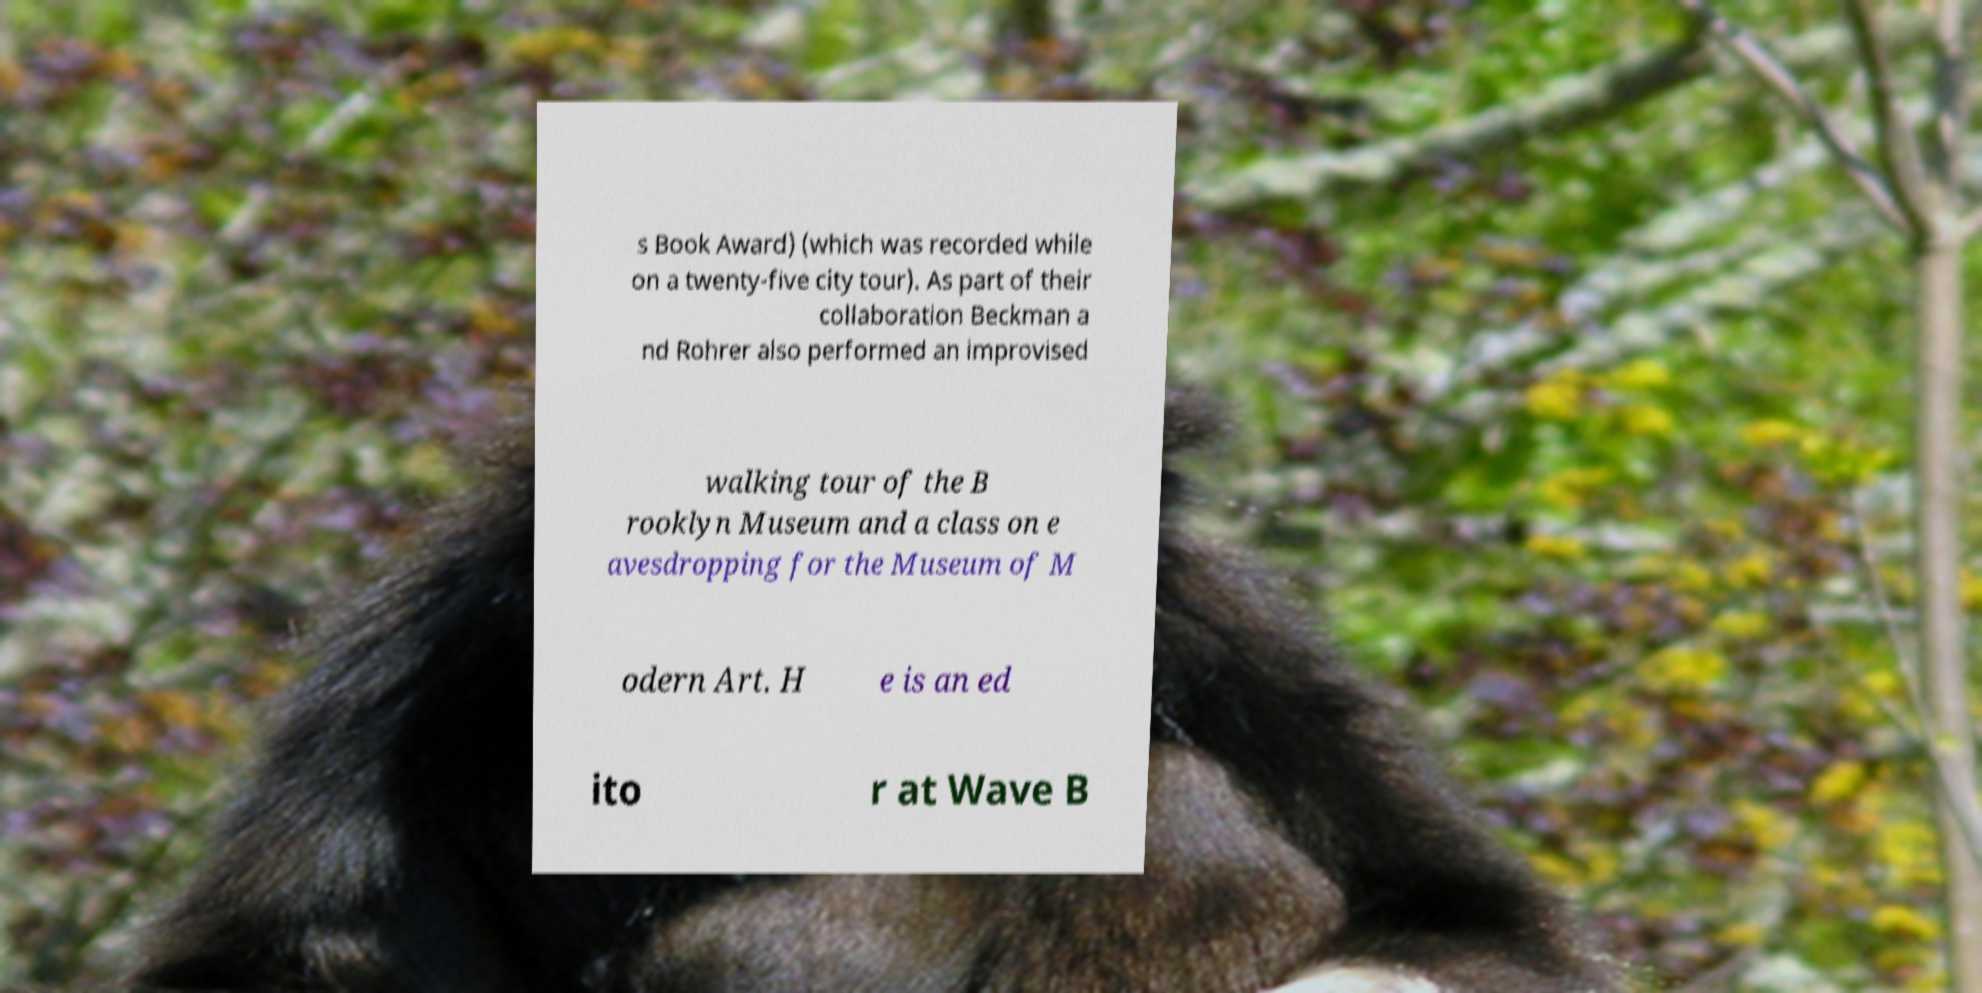Can you accurately transcribe the text from the provided image for me? s Book Award) (which was recorded while on a twenty-five city tour). As part of their collaboration Beckman a nd Rohrer also performed an improvised walking tour of the B rooklyn Museum and a class on e avesdropping for the Museum of M odern Art. H e is an ed ito r at Wave B 